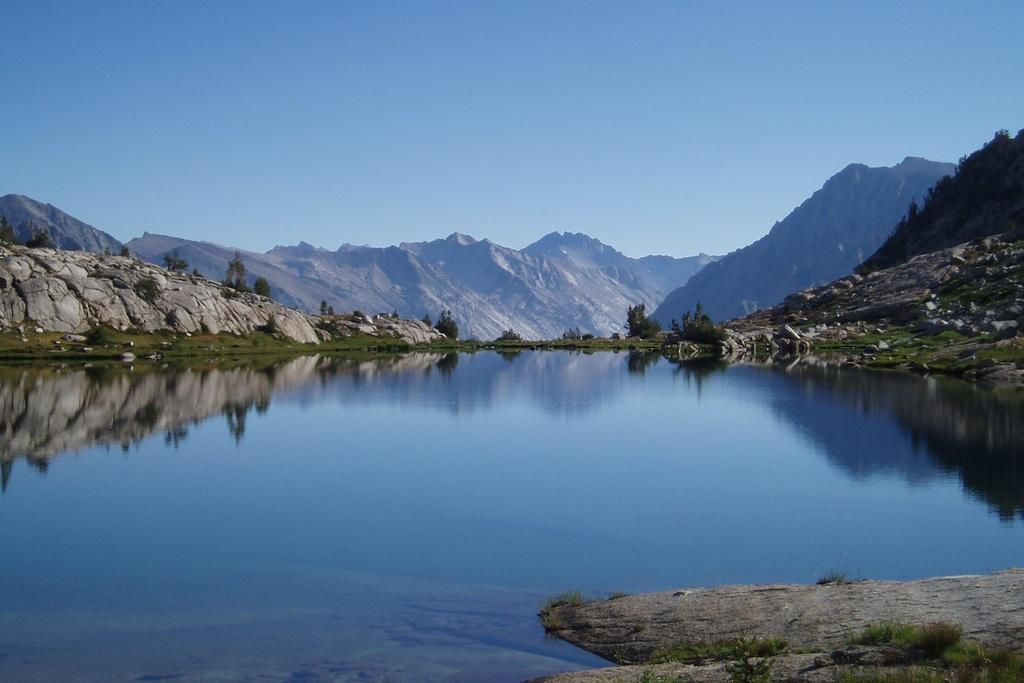What type of natural landscape is depicted in the image? The image features mountains and trees. What part of the sky is visible in the image? The sky is visible at the top of the image. What is visible at the bottom of the image? There is water visible at the bottom of the image. What type of pet can be seen playing with a ball in the image? There is no pet or ball present in the image; it features mountains, trees, sky, and water. 